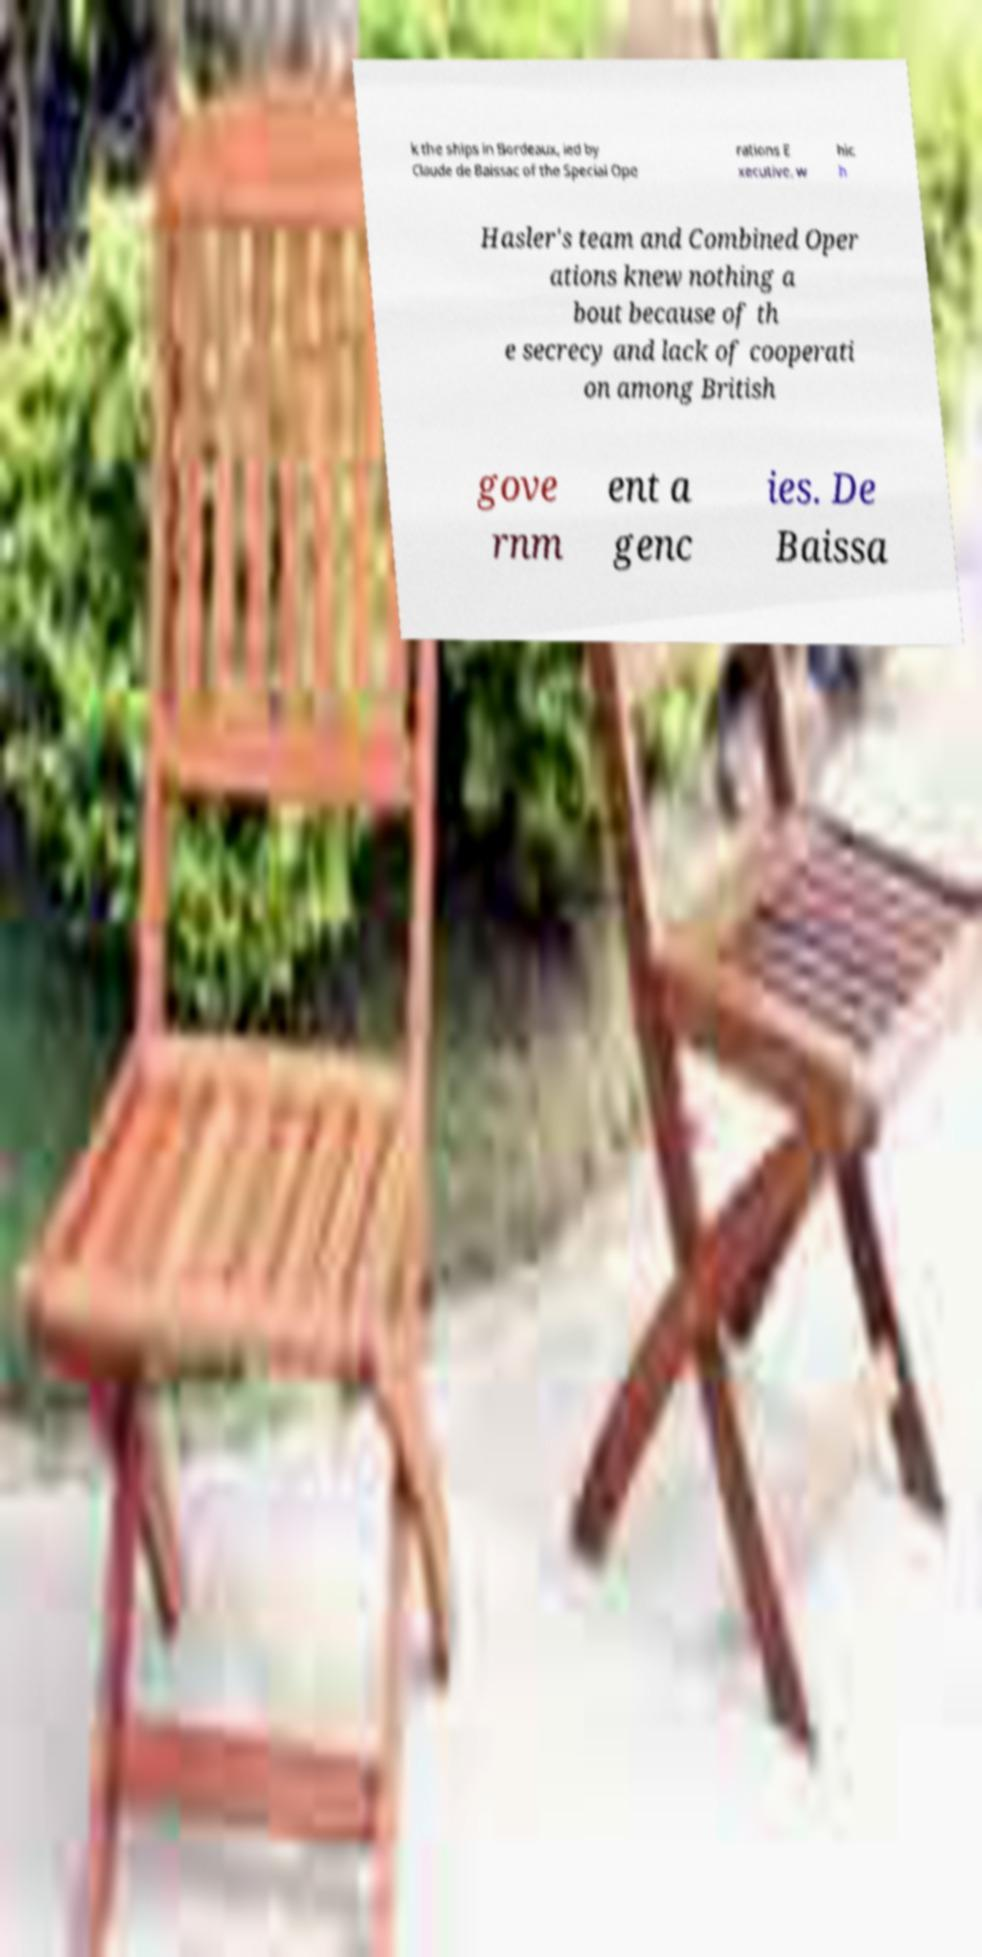Could you assist in decoding the text presented in this image and type it out clearly? k the ships in Bordeaux, led by Claude de Baissac of the Special Ope rations E xecutive, w hic h Hasler's team and Combined Oper ations knew nothing a bout because of th e secrecy and lack of cooperati on among British gove rnm ent a genc ies. De Baissa 